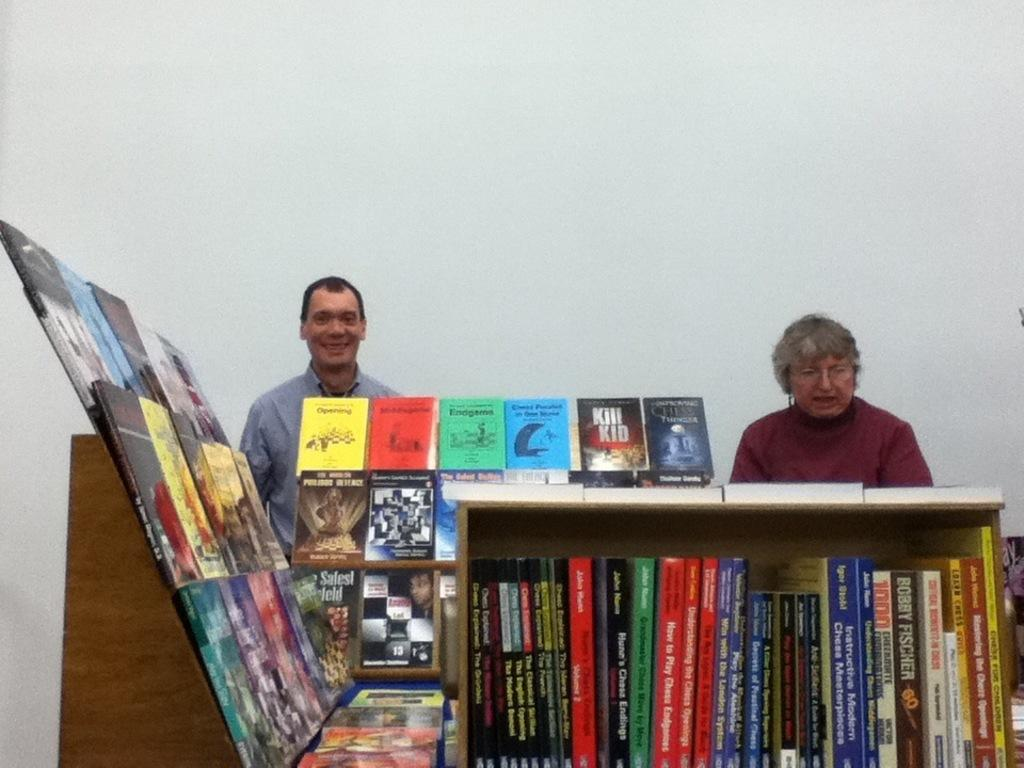Provide a one-sentence caption for the provided image. a book called how to play chess is sitting in a bookcase. 